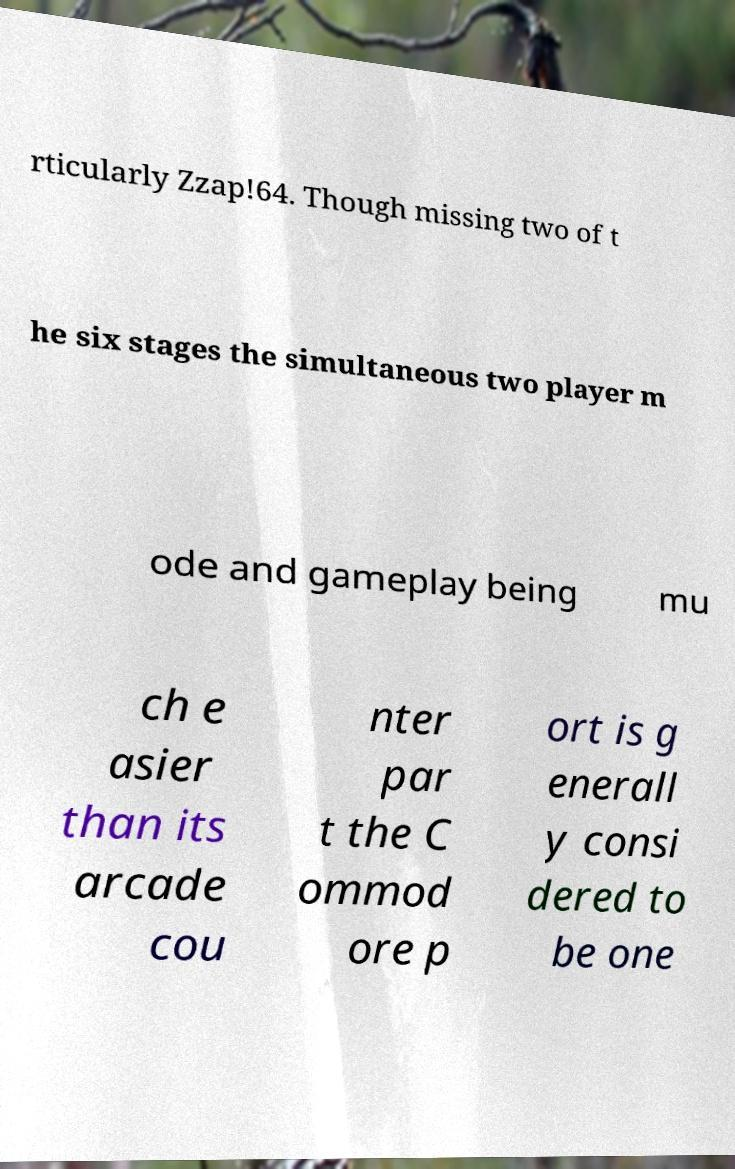Can you accurately transcribe the text from the provided image for me? rticularly Zzap!64. Though missing two of t he six stages the simultaneous two player m ode and gameplay being mu ch e asier than its arcade cou nter par t the C ommod ore p ort is g enerall y consi dered to be one 